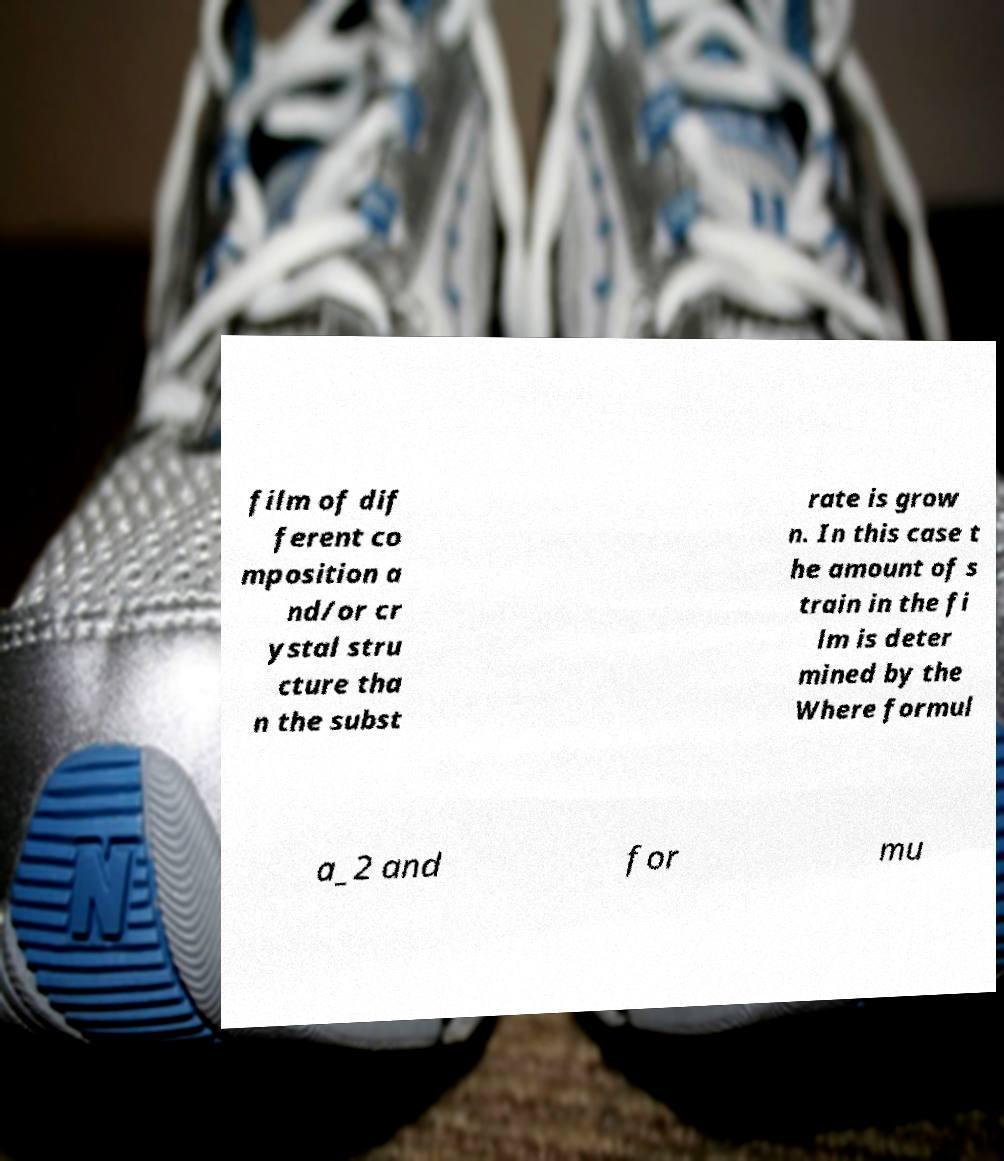For documentation purposes, I need the text within this image transcribed. Could you provide that? film of dif ferent co mposition a nd/or cr ystal stru cture tha n the subst rate is grow n. In this case t he amount of s train in the fi lm is deter mined by the Where formul a_2 and for mu 